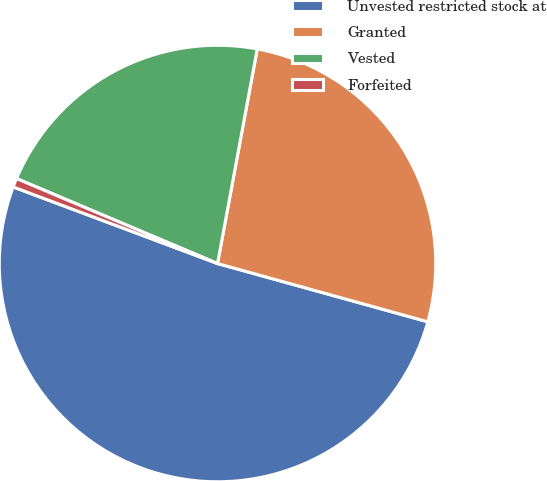<chart> <loc_0><loc_0><loc_500><loc_500><pie_chart><fcel>Unvested restricted stock at<fcel>Granted<fcel>Vested<fcel>Forfeited<nl><fcel>51.41%<fcel>26.39%<fcel>21.55%<fcel>0.66%<nl></chart> 